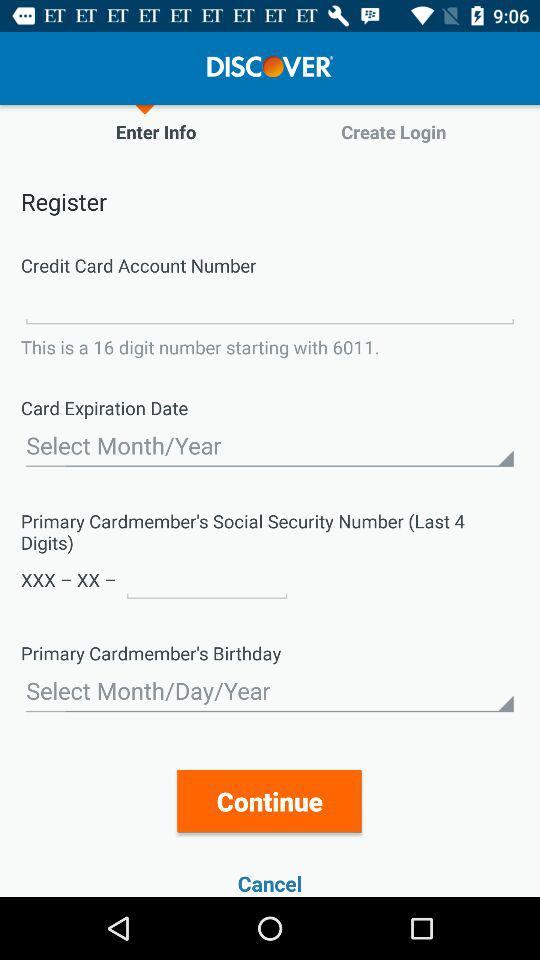What options are provided for inputting the card expiration date? The user is provided with dropdown menus to select both the Month and the Year for the card's expiration date. 